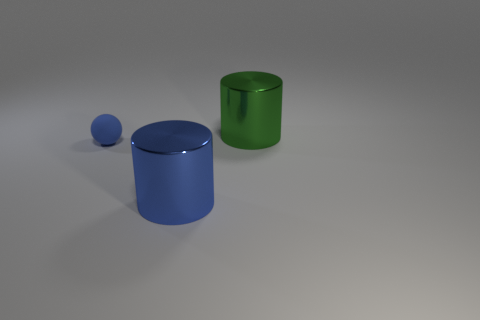Add 2 cyan metal spheres. How many objects exist? 5 Subtract all blue cylinders. Subtract all blue cylinders. How many objects are left? 1 Add 3 rubber things. How many rubber things are left? 4 Add 2 green cylinders. How many green cylinders exist? 3 Subtract 1 green cylinders. How many objects are left? 2 Subtract all cylinders. How many objects are left? 1 